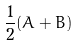<formula> <loc_0><loc_0><loc_500><loc_500>\frac { 1 } { 2 } ( A + B )</formula> 